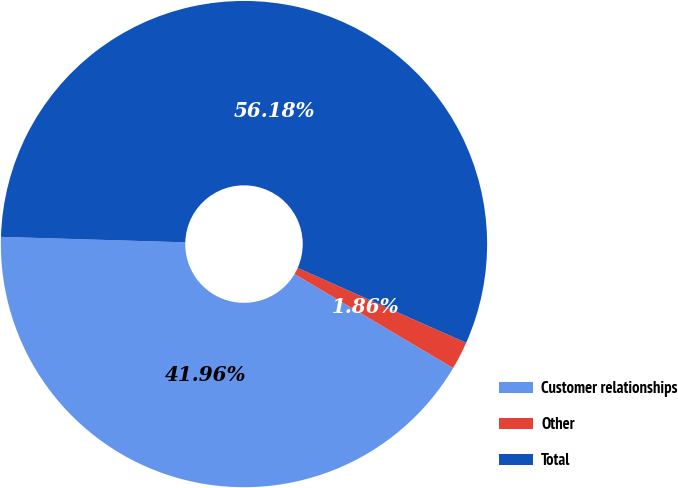<chart> <loc_0><loc_0><loc_500><loc_500><pie_chart><fcel>Customer relationships<fcel>Other<fcel>Total<nl><fcel>41.96%<fcel>1.86%<fcel>56.19%<nl></chart> 